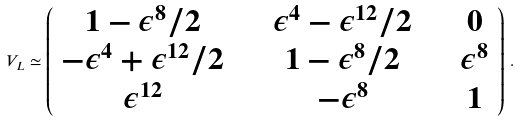Convert formula to latex. <formula><loc_0><loc_0><loc_500><loc_500>V _ { L } \simeq \left ( \begin{array} { c c c } 1 - \epsilon ^ { 8 } / 2 & \quad \epsilon ^ { 4 } - \epsilon ^ { 1 2 } / 2 & \quad 0 \\ - \epsilon ^ { 4 } + \epsilon ^ { 1 2 } / 2 & \quad 1 - \epsilon ^ { 8 } / 2 & \quad \epsilon ^ { 8 } \\ \epsilon ^ { 1 2 } & \quad - \epsilon ^ { 8 } & \quad 1 \end{array} \right ) \, .</formula> 